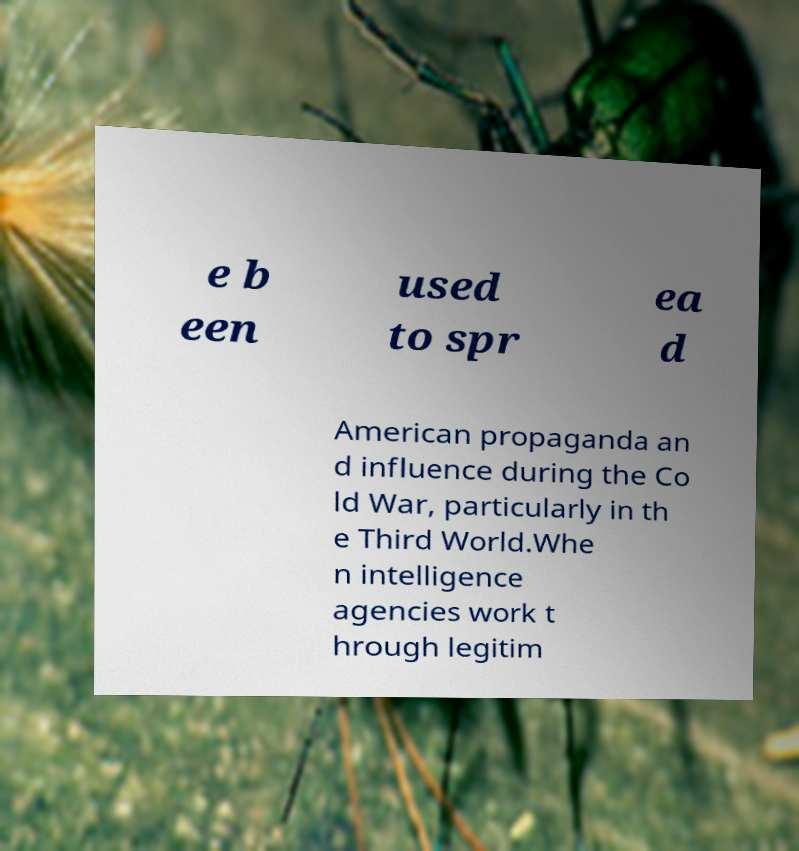Please read and relay the text visible in this image. What does it say? e b een used to spr ea d American propaganda an d influence during the Co ld War, particularly in th e Third World.Whe n intelligence agencies work t hrough legitim 